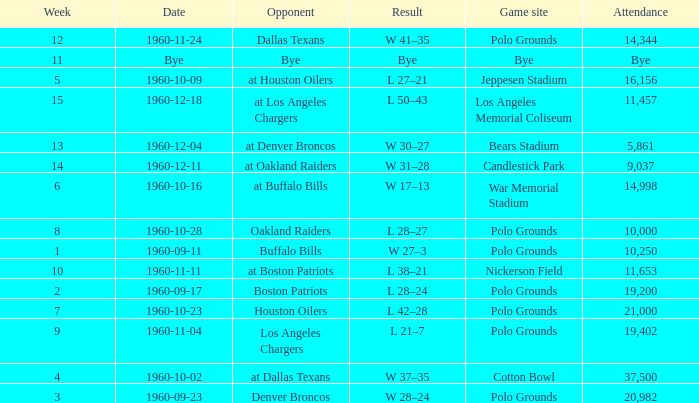What day did they play at candlestick park? 1960-12-11. 